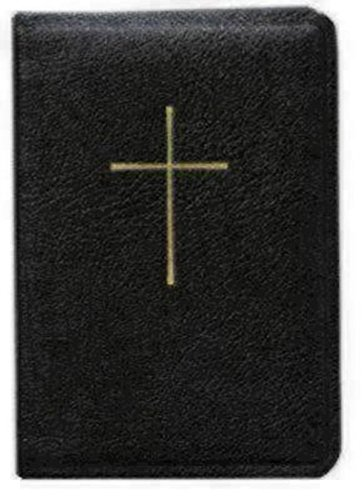In what context would you expect this book to be used? This kind of book would typically be used in Christian religious services, personal prayer, or daily devotionals, providing liturgy, scripture readings, and hymns pertinent to the faith. What indication is there that this book might be meant for regular use? The sturdy appearance and the simplicity of the design hint at practical and frequent use, such as in daily religious study or carried to church services. 